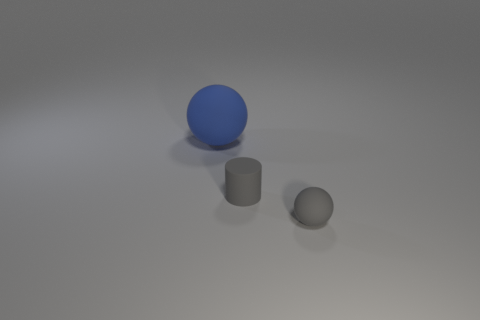Subtract all brown cylinders. Subtract all red blocks. How many cylinders are left? 1 Add 2 gray balls. How many objects exist? 5 Subtract all cylinders. How many objects are left? 2 Add 3 gray cylinders. How many gray cylinders are left? 4 Add 1 large rubber things. How many large rubber things exist? 2 Subtract 0 yellow cylinders. How many objects are left? 3 Subtract all small green shiny balls. Subtract all big things. How many objects are left? 2 